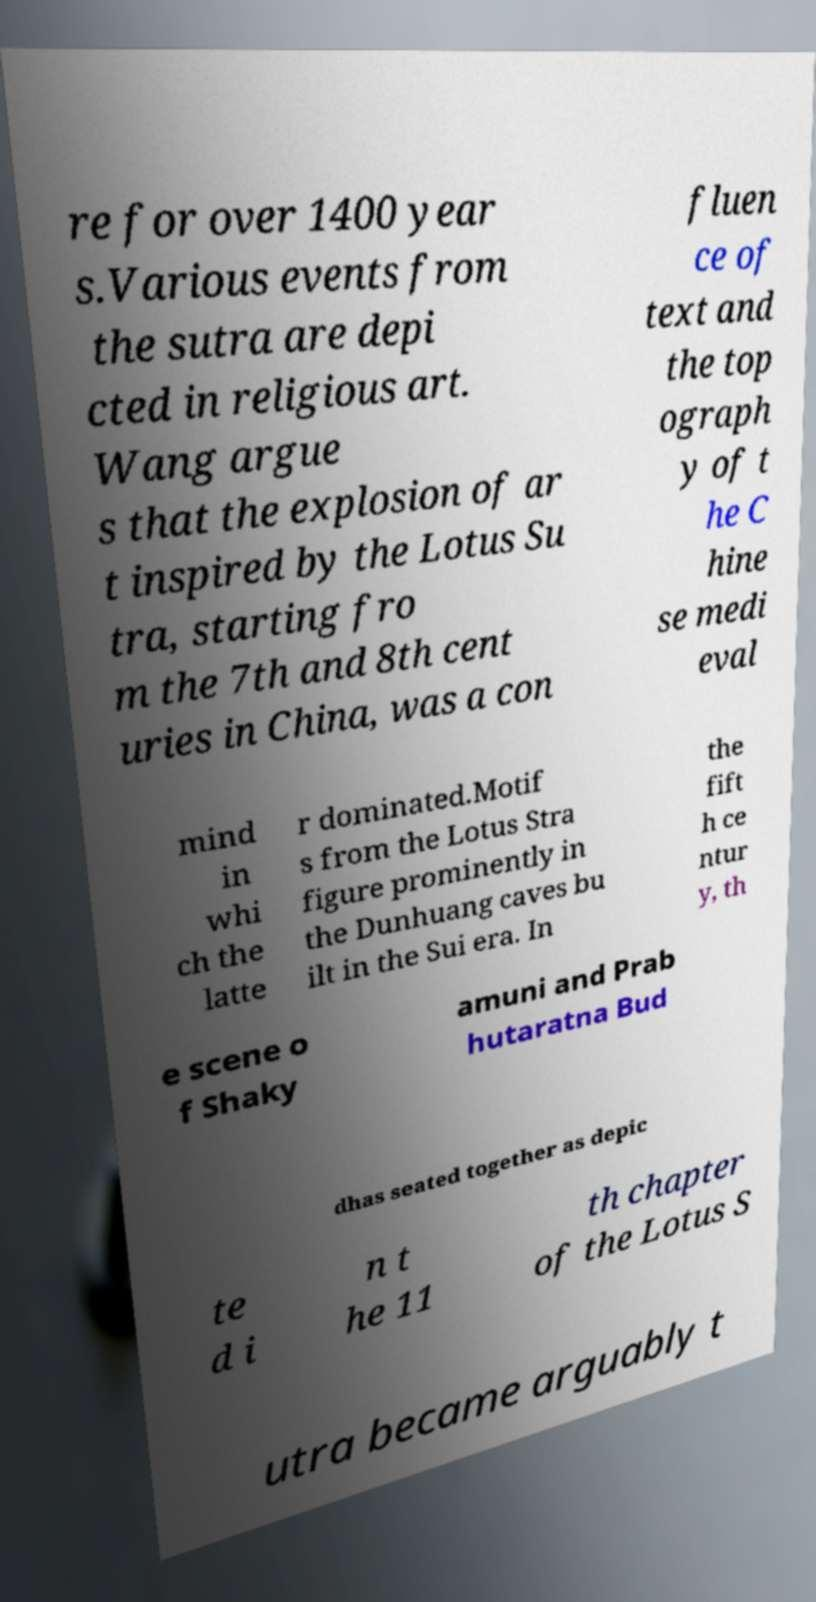There's text embedded in this image that I need extracted. Can you transcribe it verbatim? re for over 1400 year s.Various events from the sutra are depi cted in religious art. Wang argue s that the explosion of ar t inspired by the Lotus Su tra, starting fro m the 7th and 8th cent uries in China, was a con fluen ce of text and the top ograph y of t he C hine se medi eval mind in whi ch the latte r dominated.Motif s from the Lotus Stra figure prominently in the Dunhuang caves bu ilt in the Sui era. In the fift h ce ntur y, th e scene o f Shaky amuni and Prab hutaratna Bud dhas seated together as depic te d i n t he 11 th chapter of the Lotus S utra became arguably t 